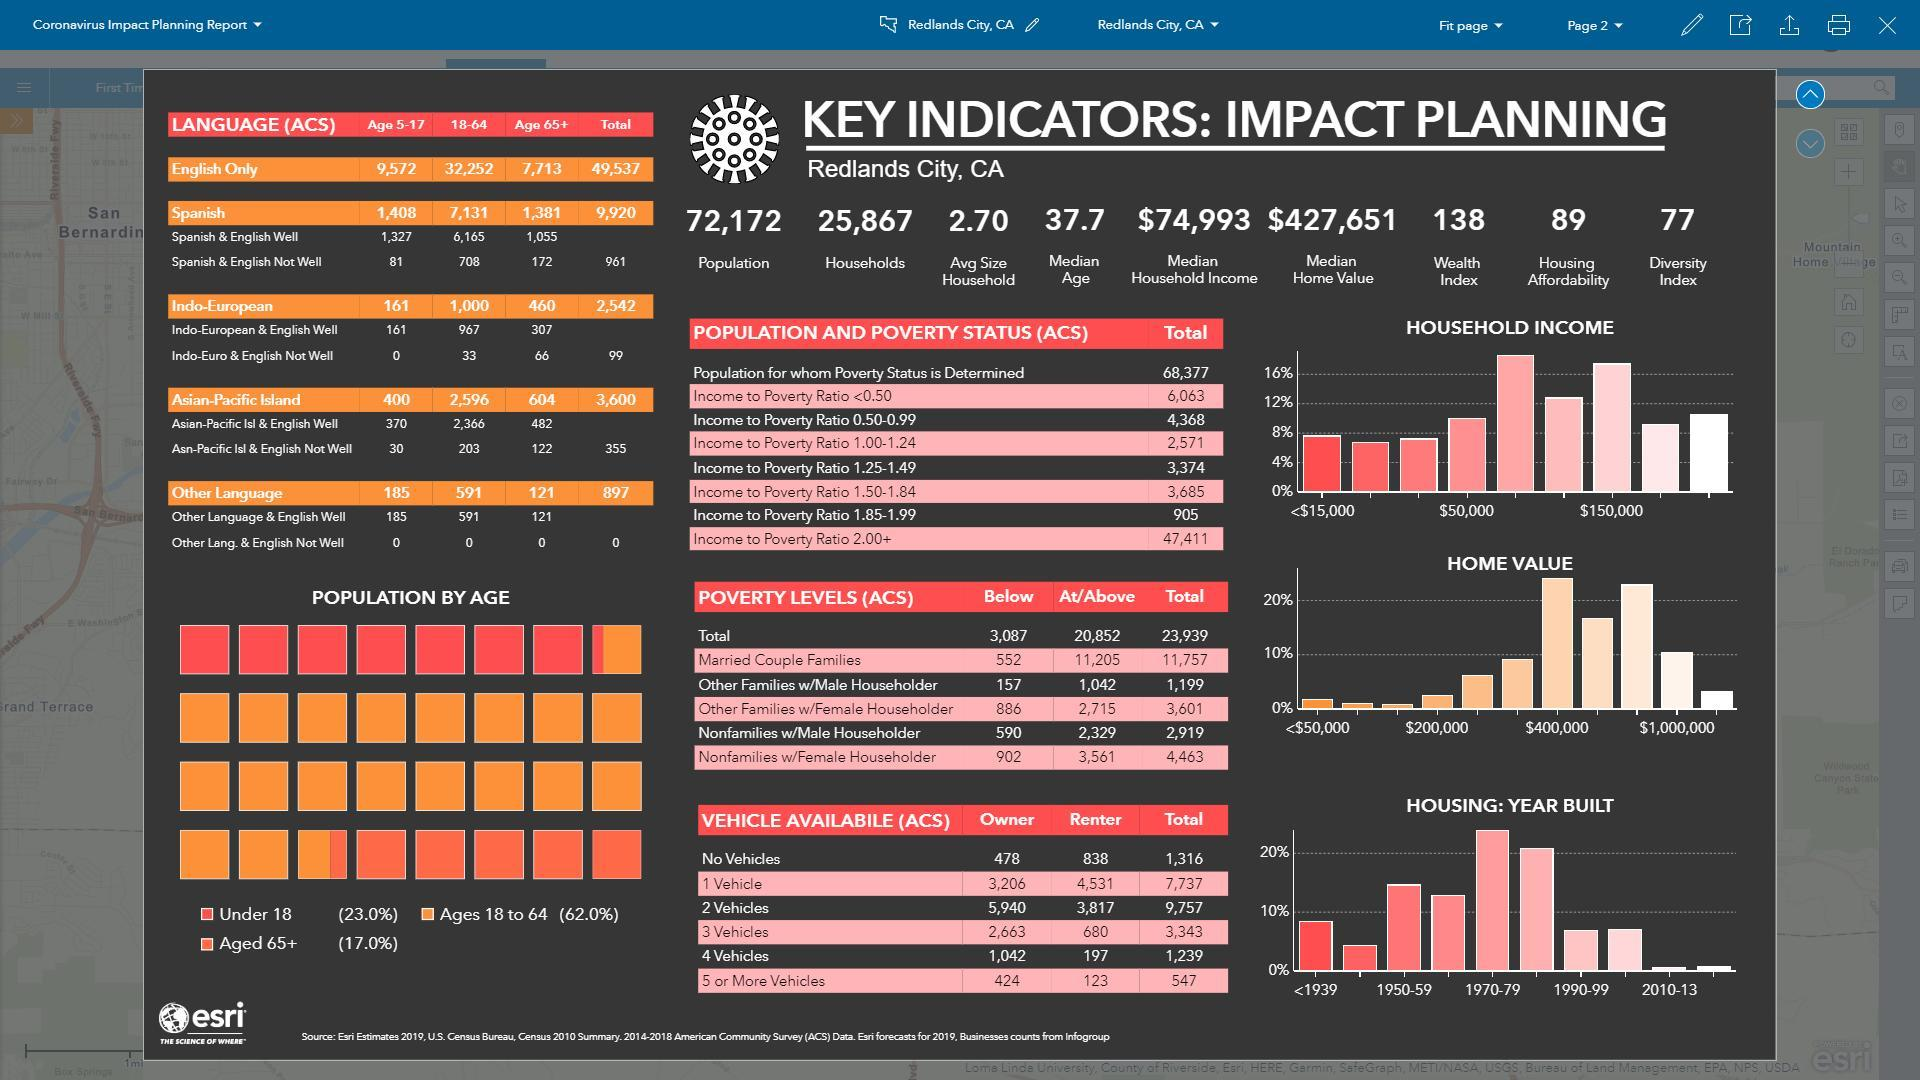How many people aged 18-64 years speak only spanish language in the Redlands City, CA as per the ACS data?
Answer the question with a short phrase. 7,131 How many people aged 5-17 years speak only indo-european language in the Redlands City, CA as per the ACS data? 161 How many people aged 65+ speak both english & indo-european language well in the Redlands City, CA as per the ACS data? 307 What is the median household income in the Redlands City, CA? $74,993 How many people aged 65+ speak both english & spanish language well in the Redlands City, CA as per the ACS data? 1,055 What is the median home value in the Redlands City, CA? $427,651 What is the average household size in the Redlands City, CA? 2.70 What is the diversity index in the Redlands City, CA? 77 What is the number of households in the Redlands City, CA? 25,867 How many people aged 65+ speak only english language in the Redlands City, CA as per the ACS data? 7,713 